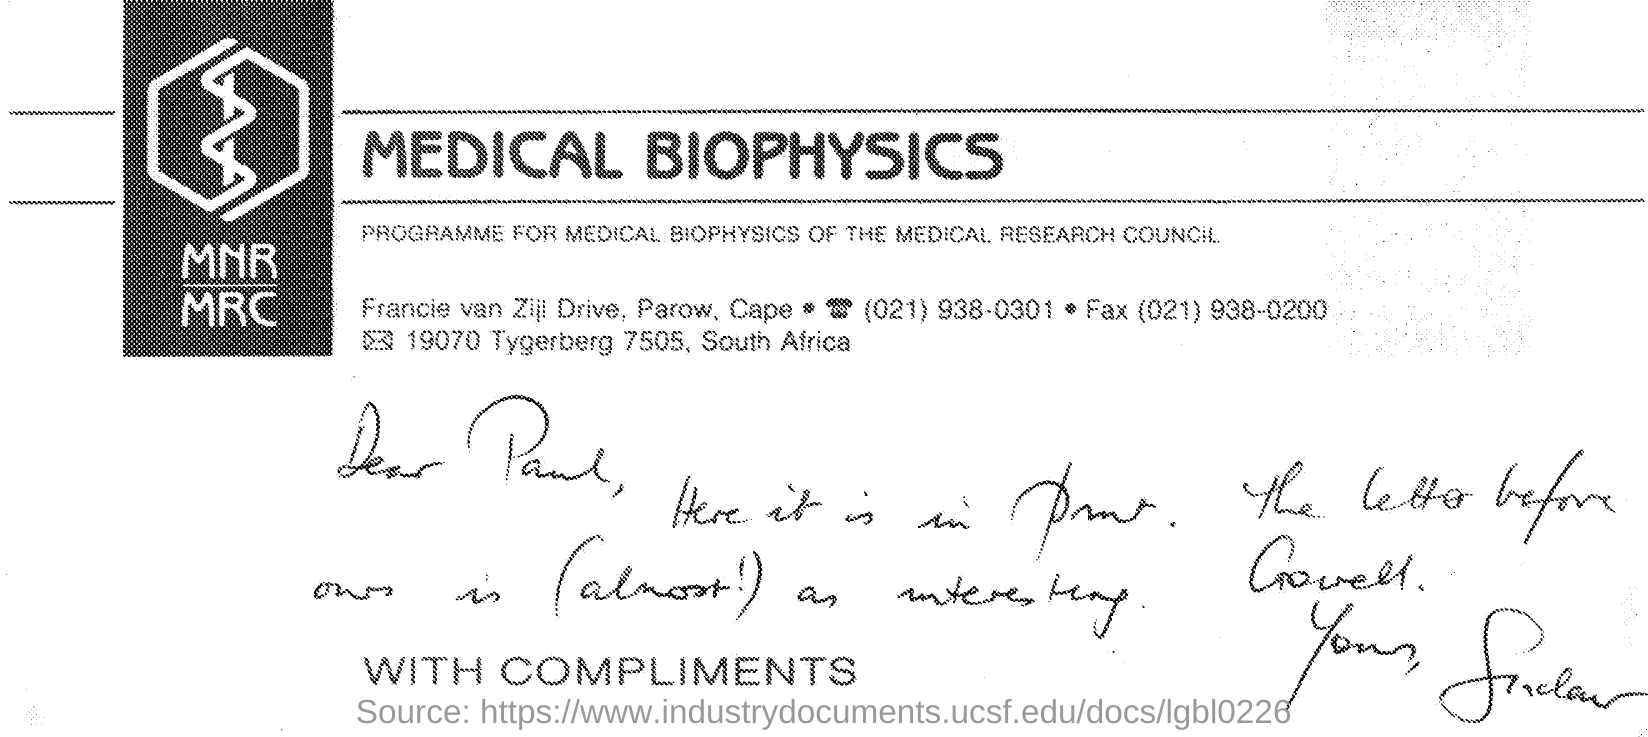What is the title of the document ?
Your answer should be very brief. MEDICAL BIOPHYSICS. Who is the person mentioned as dear in the letter ?
Your response must be concise. PAUL. 